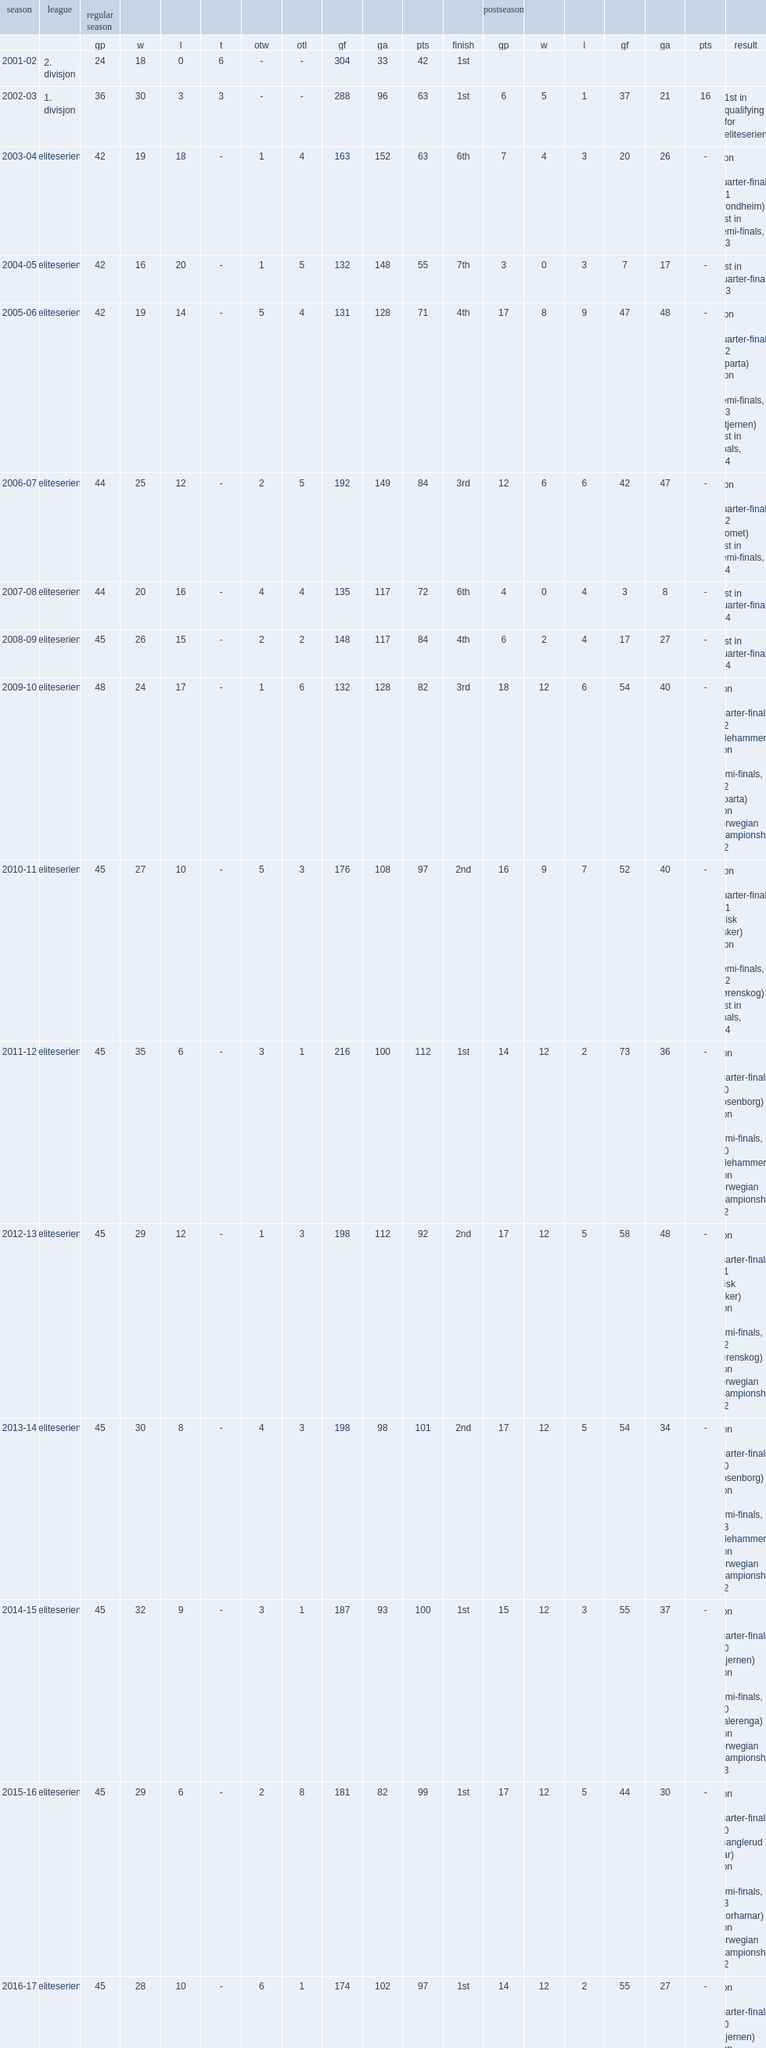As of 2017, how many gp have they completed fourteen seasons in the eliteserien? 359.0. 